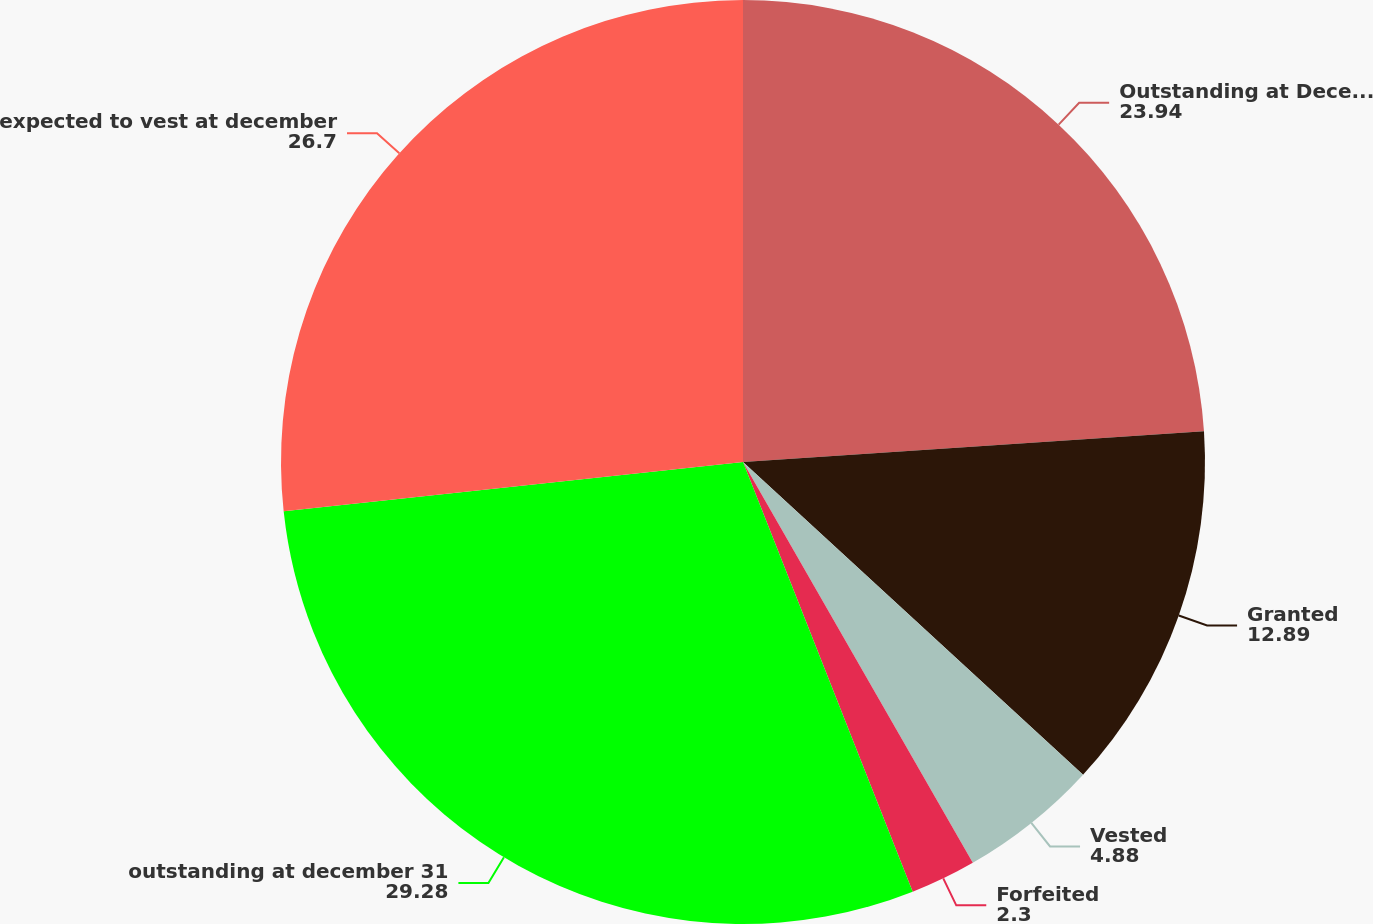<chart> <loc_0><loc_0><loc_500><loc_500><pie_chart><fcel>Outstanding at December 31<fcel>Granted<fcel>Vested<fcel>Forfeited<fcel>outstanding at december 31<fcel>expected to vest at december<nl><fcel>23.94%<fcel>12.89%<fcel>4.88%<fcel>2.3%<fcel>29.28%<fcel>26.7%<nl></chart> 